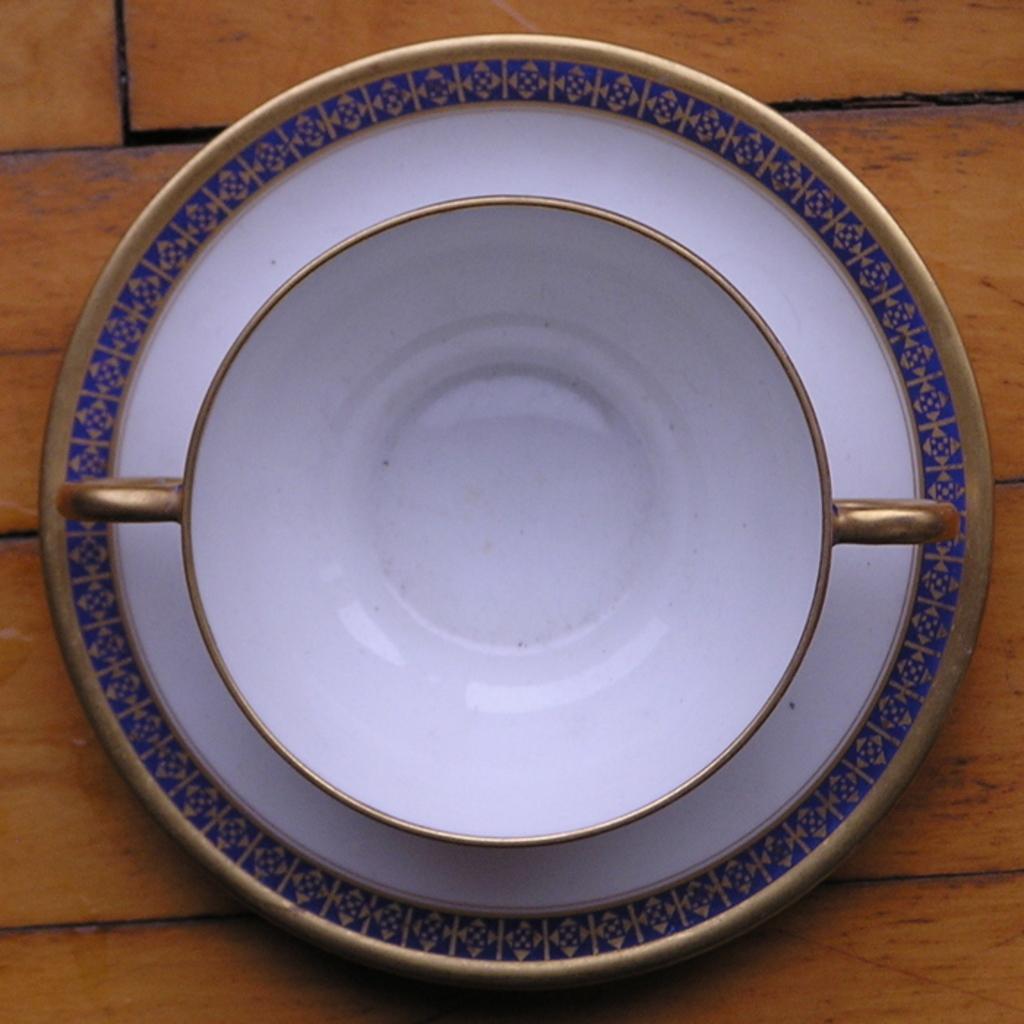Could you give a brief overview of what you see in this image? In this image we can see a plate and bowl kept on the wooden surface. 